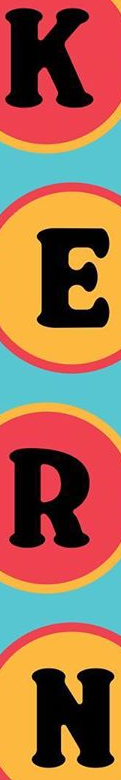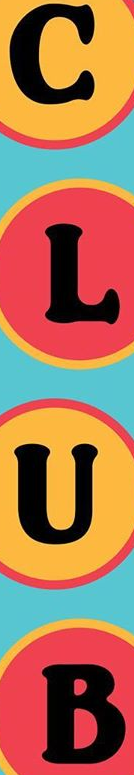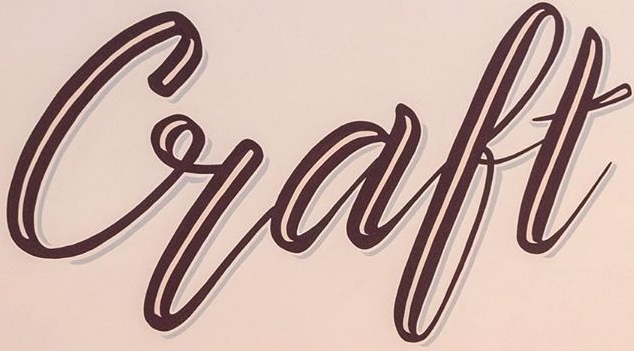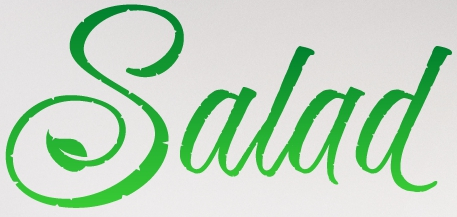Read the text content from these images in order, separated by a semicolon. KERT; CLUB; Craft; Salad 